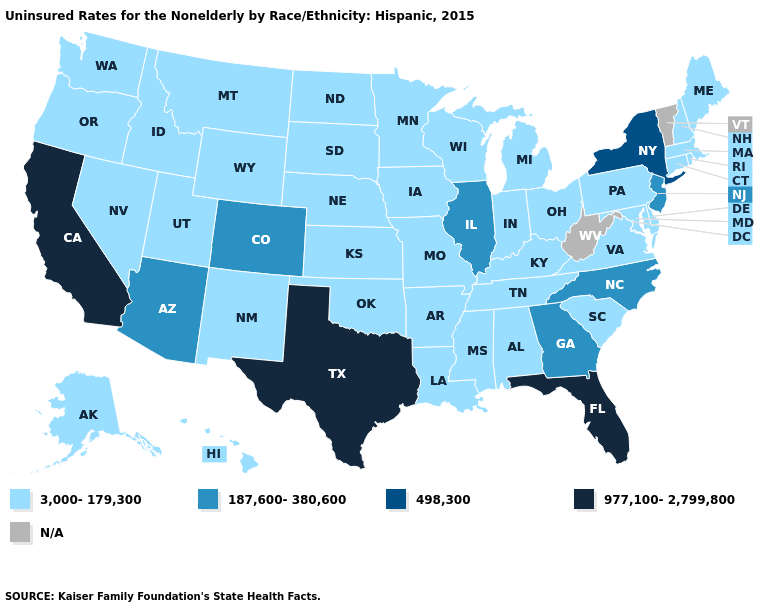Does Utah have the highest value in the West?
Answer briefly. No. Name the states that have a value in the range 498,300?
Answer briefly. New York. Name the states that have a value in the range 977,100-2,799,800?
Be succinct. California, Florida, Texas. Is the legend a continuous bar?
Answer briefly. No. What is the lowest value in the USA?
Answer briefly. 3,000-179,300. Does Utah have the lowest value in the West?
Keep it brief. Yes. Which states have the lowest value in the West?
Keep it brief. Alaska, Hawaii, Idaho, Montana, Nevada, New Mexico, Oregon, Utah, Washington, Wyoming. What is the value of Massachusetts?
Keep it brief. 3,000-179,300. Does New York have the lowest value in the Northeast?
Answer briefly. No. What is the lowest value in states that border Pennsylvania?
Quick response, please. 3,000-179,300. What is the lowest value in the USA?
Answer briefly. 3,000-179,300. Which states hav the highest value in the Northeast?
Write a very short answer. New York. Which states have the lowest value in the South?
Quick response, please. Alabama, Arkansas, Delaware, Kentucky, Louisiana, Maryland, Mississippi, Oklahoma, South Carolina, Tennessee, Virginia. 